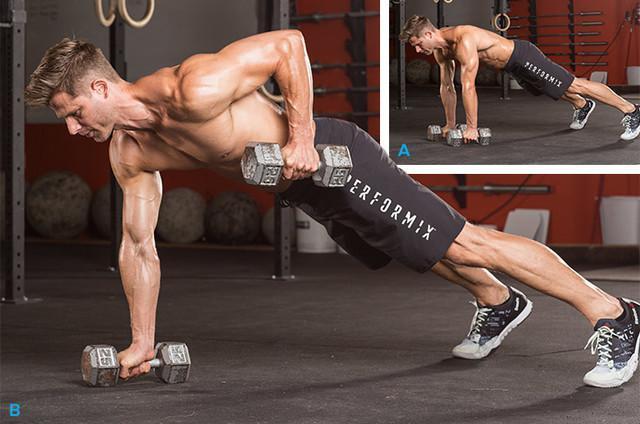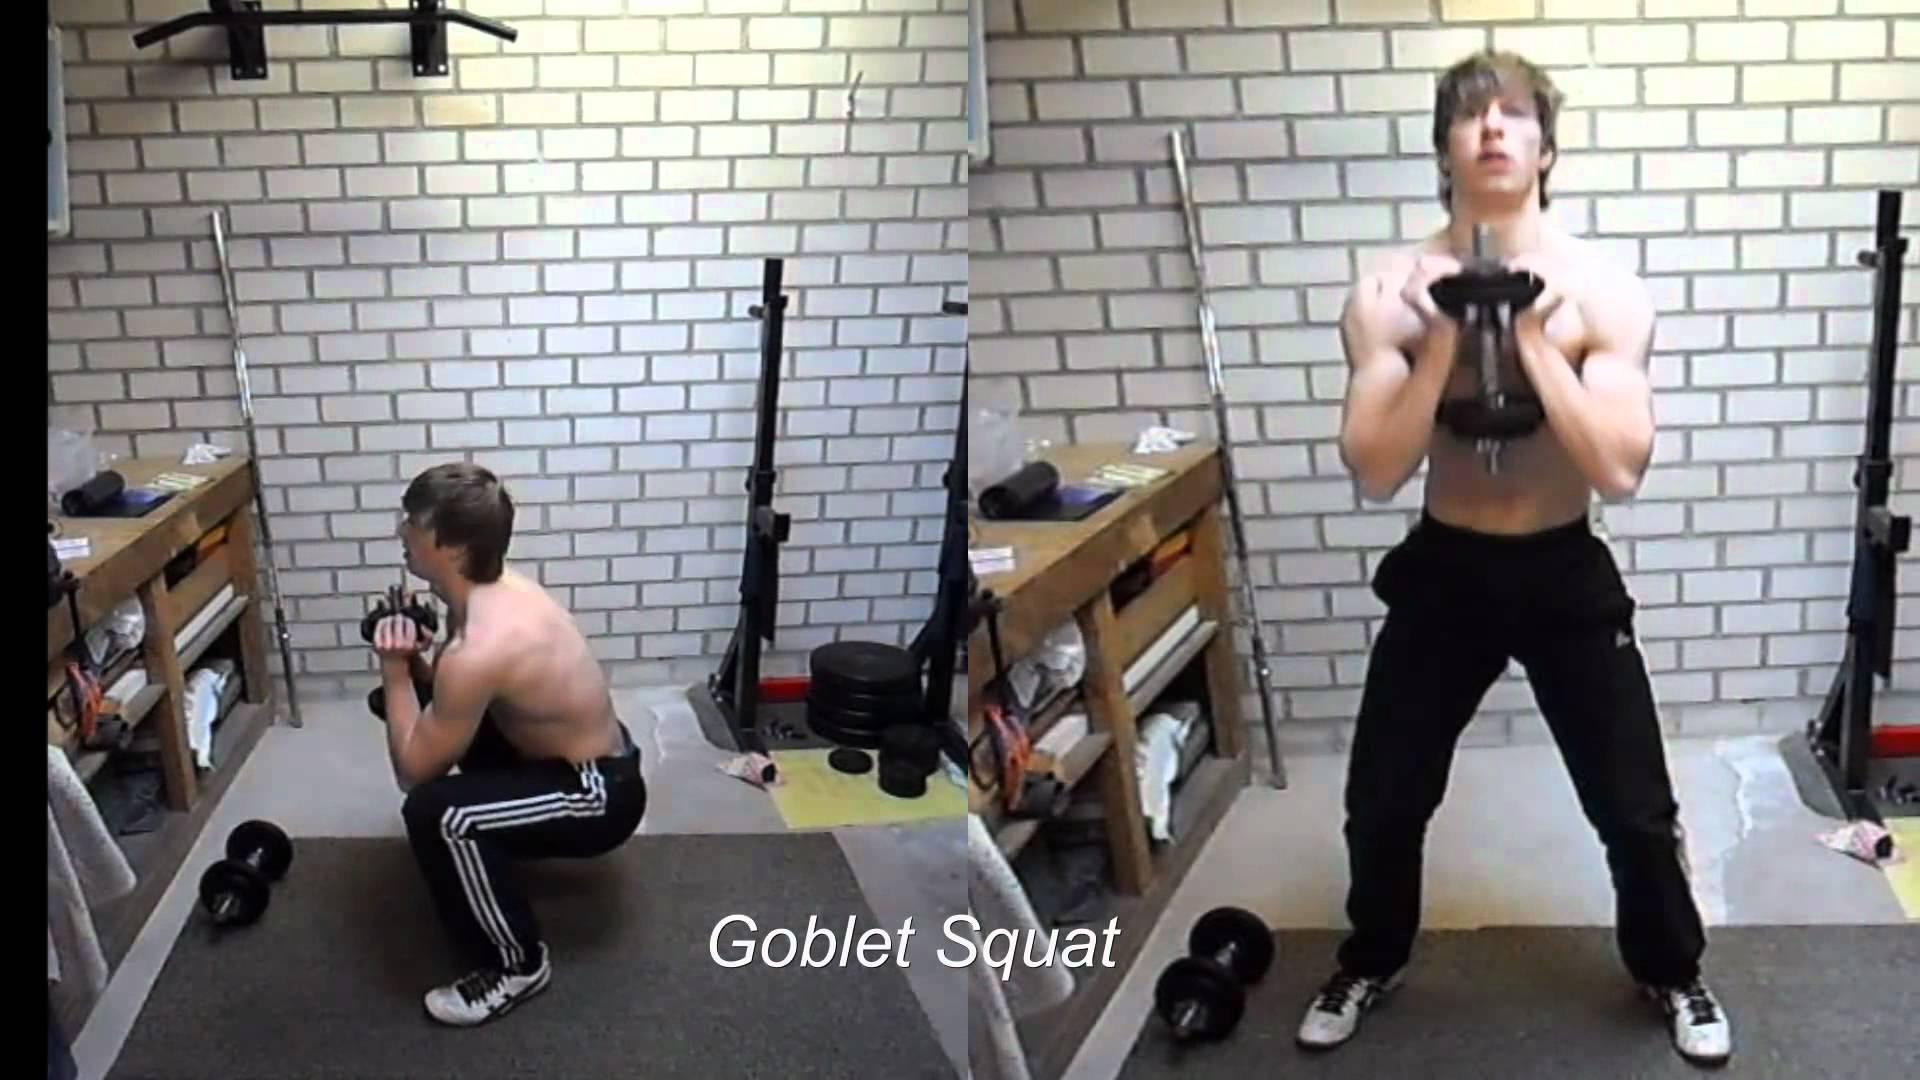The first image is the image on the left, the second image is the image on the right. Considering the images on both sides, is "In one image a bodybuilder, facing the floor, is balanced on the toes of his feet and has at least one hand on the floor gripping a small barbell." valid? Answer yes or no. Yes. 